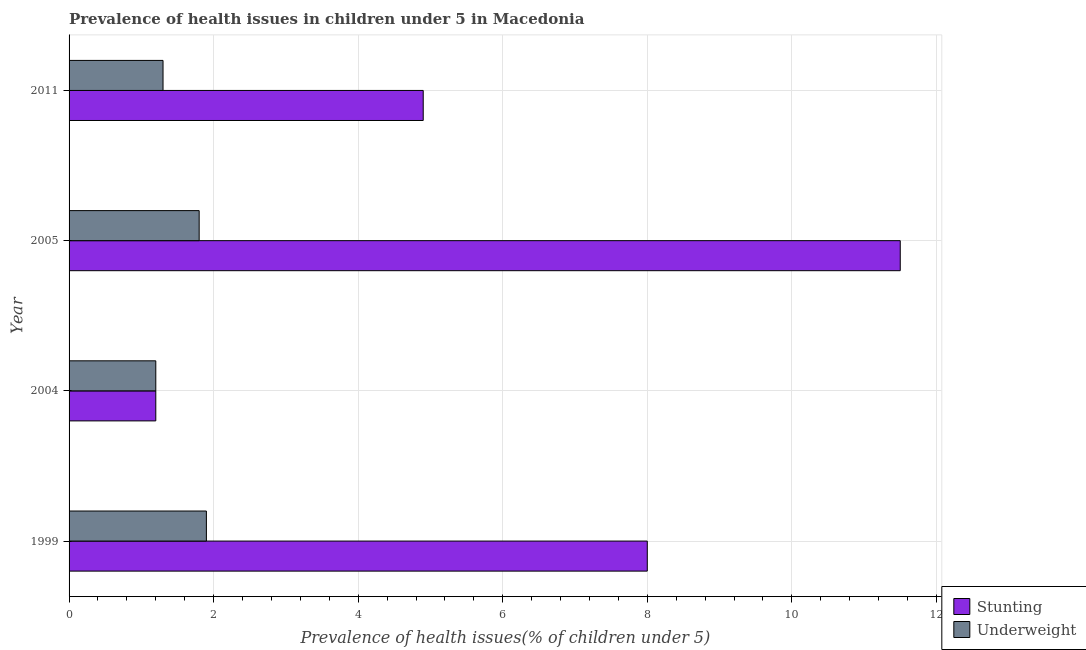How many groups of bars are there?
Give a very brief answer. 4. Are the number of bars on each tick of the Y-axis equal?
Keep it short and to the point. Yes. How many bars are there on the 2nd tick from the top?
Your answer should be compact. 2. How many bars are there on the 2nd tick from the bottom?
Offer a terse response. 2. What is the label of the 4th group of bars from the top?
Offer a terse response. 1999. What is the percentage of stunted children in 2011?
Your answer should be compact. 4.9. Across all years, what is the minimum percentage of underweight children?
Your answer should be very brief. 1.2. What is the total percentage of underweight children in the graph?
Make the answer very short. 6.2. What is the difference between the percentage of stunted children in 2005 and that in 2011?
Give a very brief answer. 6.6. What is the ratio of the percentage of underweight children in 2004 to that in 2011?
Provide a short and direct response. 0.92. Is the percentage of stunted children in 2005 less than that in 2011?
Provide a succinct answer. No. What is the difference between the highest and the lowest percentage of stunted children?
Give a very brief answer. 10.3. In how many years, is the percentage of stunted children greater than the average percentage of stunted children taken over all years?
Make the answer very short. 2. What does the 2nd bar from the top in 2004 represents?
Offer a terse response. Stunting. What does the 1st bar from the bottom in 2004 represents?
Offer a terse response. Stunting. How many bars are there?
Provide a succinct answer. 8. Are all the bars in the graph horizontal?
Make the answer very short. Yes. What is the difference between two consecutive major ticks on the X-axis?
Keep it short and to the point. 2. Are the values on the major ticks of X-axis written in scientific E-notation?
Ensure brevity in your answer.  No. Does the graph contain any zero values?
Offer a terse response. No. Does the graph contain grids?
Provide a succinct answer. Yes. What is the title of the graph?
Your answer should be compact. Prevalence of health issues in children under 5 in Macedonia. What is the label or title of the X-axis?
Your answer should be very brief. Prevalence of health issues(% of children under 5). What is the label or title of the Y-axis?
Provide a succinct answer. Year. What is the Prevalence of health issues(% of children under 5) of Underweight in 1999?
Your response must be concise. 1.9. What is the Prevalence of health issues(% of children under 5) in Stunting in 2004?
Your answer should be very brief. 1.2. What is the Prevalence of health issues(% of children under 5) of Underweight in 2005?
Provide a succinct answer. 1.8. What is the Prevalence of health issues(% of children under 5) in Stunting in 2011?
Provide a short and direct response. 4.9. What is the Prevalence of health issues(% of children under 5) of Underweight in 2011?
Provide a short and direct response. 1.3. Across all years, what is the maximum Prevalence of health issues(% of children under 5) in Stunting?
Make the answer very short. 11.5. Across all years, what is the maximum Prevalence of health issues(% of children under 5) of Underweight?
Offer a terse response. 1.9. Across all years, what is the minimum Prevalence of health issues(% of children under 5) in Stunting?
Your response must be concise. 1.2. What is the total Prevalence of health issues(% of children under 5) in Stunting in the graph?
Your response must be concise. 25.6. What is the difference between the Prevalence of health issues(% of children under 5) of Stunting in 1999 and that in 2004?
Your response must be concise. 6.8. What is the difference between the Prevalence of health issues(% of children under 5) in Stunting in 1999 and that in 2005?
Ensure brevity in your answer.  -3.5. What is the difference between the Prevalence of health issues(% of children under 5) in Underweight in 1999 and that in 2005?
Offer a very short reply. 0.1. What is the difference between the Prevalence of health issues(% of children under 5) of Underweight in 1999 and that in 2011?
Your response must be concise. 0.6. What is the difference between the Prevalence of health issues(% of children under 5) in Stunting in 2004 and that in 2011?
Your answer should be compact. -3.7. What is the difference between the Prevalence of health issues(% of children under 5) of Underweight in 2004 and that in 2011?
Ensure brevity in your answer.  -0.1. What is the difference between the Prevalence of health issues(% of children under 5) in Stunting in 2005 and that in 2011?
Your answer should be compact. 6.6. What is the difference between the Prevalence of health issues(% of children under 5) in Underweight in 2005 and that in 2011?
Give a very brief answer. 0.5. What is the difference between the Prevalence of health issues(% of children under 5) in Stunting in 1999 and the Prevalence of health issues(% of children under 5) in Underweight in 2004?
Give a very brief answer. 6.8. What is the difference between the Prevalence of health issues(% of children under 5) in Stunting in 1999 and the Prevalence of health issues(% of children under 5) in Underweight in 2005?
Make the answer very short. 6.2. What is the difference between the Prevalence of health issues(% of children under 5) of Stunting in 2004 and the Prevalence of health issues(% of children under 5) of Underweight in 2005?
Offer a terse response. -0.6. What is the difference between the Prevalence of health issues(% of children under 5) in Stunting in 2004 and the Prevalence of health issues(% of children under 5) in Underweight in 2011?
Keep it short and to the point. -0.1. What is the difference between the Prevalence of health issues(% of children under 5) in Stunting in 2005 and the Prevalence of health issues(% of children under 5) in Underweight in 2011?
Offer a very short reply. 10.2. What is the average Prevalence of health issues(% of children under 5) in Stunting per year?
Ensure brevity in your answer.  6.4. What is the average Prevalence of health issues(% of children under 5) of Underweight per year?
Give a very brief answer. 1.55. In the year 2005, what is the difference between the Prevalence of health issues(% of children under 5) of Stunting and Prevalence of health issues(% of children under 5) of Underweight?
Your response must be concise. 9.7. In the year 2011, what is the difference between the Prevalence of health issues(% of children under 5) of Stunting and Prevalence of health issues(% of children under 5) of Underweight?
Your answer should be very brief. 3.6. What is the ratio of the Prevalence of health issues(% of children under 5) of Stunting in 1999 to that in 2004?
Your response must be concise. 6.67. What is the ratio of the Prevalence of health issues(% of children under 5) in Underweight in 1999 to that in 2004?
Offer a terse response. 1.58. What is the ratio of the Prevalence of health issues(% of children under 5) of Stunting in 1999 to that in 2005?
Your answer should be very brief. 0.7. What is the ratio of the Prevalence of health issues(% of children under 5) of Underweight in 1999 to that in 2005?
Provide a short and direct response. 1.06. What is the ratio of the Prevalence of health issues(% of children under 5) of Stunting in 1999 to that in 2011?
Provide a succinct answer. 1.63. What is the ratio of the Prevalence of health issues(% of children under 5) in Underweight in 1999 to that in 2011?
Ensure brevity in your answer.  1.46. What is the ratio of the Prevalence of health issues(% of children under 5) in Stunting in 2004 to that in 2005?
Offer a very short reply. 0.1. What is the ratio of the Prevalence of health issues(% of children under 5) of Stunting in 2004 to that in 2011?
Your response must be concise. 0.24. What is the ratio of the Prevalence of health issues(% of children under 5) of Underweight in 2004 to that in 2011?
Provide a short and direct response. 0.92. What is the ratio of the Prevalence of health issues(% of children under 5) in Stunting in 2005 to that in 2011?
Keep it short and to the point. 2.35. What is the ratio of the Prevalence of health issues(% of children under 5) of Underweight in 2005 to that in 2011?
Provide a succinct answer. 1.38. What is the difference between the highest and the second highest Prevalence of health issues(% of children under 5) in Underweight?
Provide a succinct answer. 0.1. What is the difference between the highest and the lowest Prevalence of health issues(% of children under 5) of Stunting?
Offer a very short reply. 10.3. 